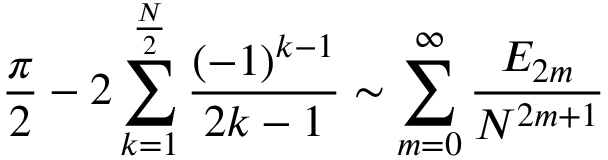Convert formula to latex. <formula><loc_0><loc_0><loc_500><loc_500>{ \frac { \pi } { 2 } } - 2 \sum _ { k = 1 } ^ { \frac { N } { 2 } } { \frac { ( - 1 ) ^ { k - 1 } } { 2 k - 1 } } \sim \sum _ { m = 0 } ^ { \infty } { \frac { E _ { 2 m } } { N ^ { 2 m + 1 } } }</formula> 